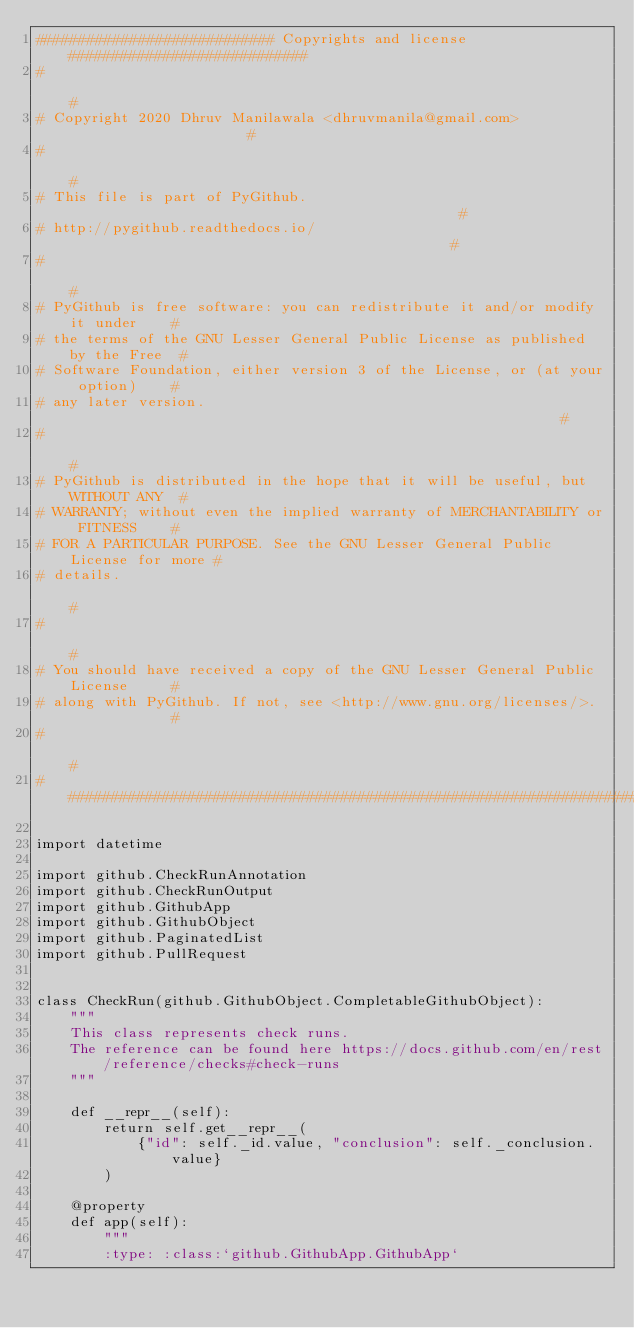Convert code to text. <code><loc_0><loc_0><loc_500><loc_500><_Python_>############################ Copyrights and license ############################
#                                                                              #
# Copyright 2020 Dhruv Manilawala <dhruvmanila@gmail.com>                      #
#                                                                              #
# This file is part of PyGithub.                                               #
# http://pygithub.readthedocs.io/                                              #
#                                                                              #
# PyGithub is free software: you can redistribute it and/or modify it under    #
# the terms of the GNU Lesser General Public License as published by the Free  #
# Software Foundation, either version 3 of the License, or (at your option)    #
# any later version.                                                           #
#                                                                              #
# PyGithub is distributed in the hope that it will be useful, but WITHOUT ANY  #
# WARRANTY; without even the implied warranty of MERCHANTABILITY or FITNESS    #
# FOR A PARTICULAR PURPOSE. See the GNU Lesser General Public License for more #
# details.                                                                     #
#                                                                              #
# You should have received a copy of the GNU Lesser General Public License     #
# along with PyGithub. If not, see <http://www.gnu.org/licenses/>.             #
#                                                                              #
################################################################################

import datetime

import github.CheckRunAnnotation
import github.CheckRunOutput
import github.GithubApp
import github.GithubObject
import github.PaginatedList
import github.PullRequest


class CheckRun(github.GithubObject.CompletableGithubObject):
    """
    This class represents check runs.
    The reference can be found here https://docs.github.com/en/rest/reference/checks#check-runs
    """

    def __repr__(self):
        return self.get__repr__(
            {"id": self._id.value, "conclusion": self._conclusion.value}
        )

    @property
    def app(self):
        """
        :type: :class:`github.GithubApp.GithubApp`</code> 